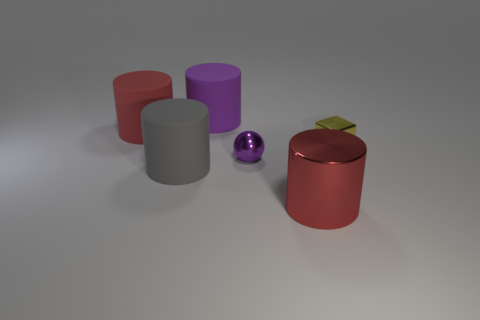Add 2 small metallic blocks. How many objects exist? 8 Subtract all cylinders. How many objects are left? 2 Add 5 big cylinders. How many big cylinders exist? 9 Subtract 0 yellow cylinders. How many objects are left? 6 Subtract all blue cylinders. Subtract all cubes. How many objects are left? 5 Add 2 small purple balls. How many small purple balls are left? 3 